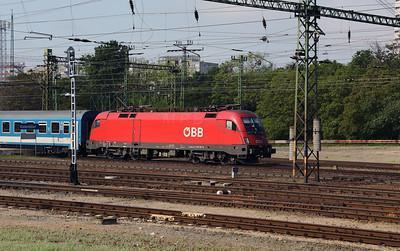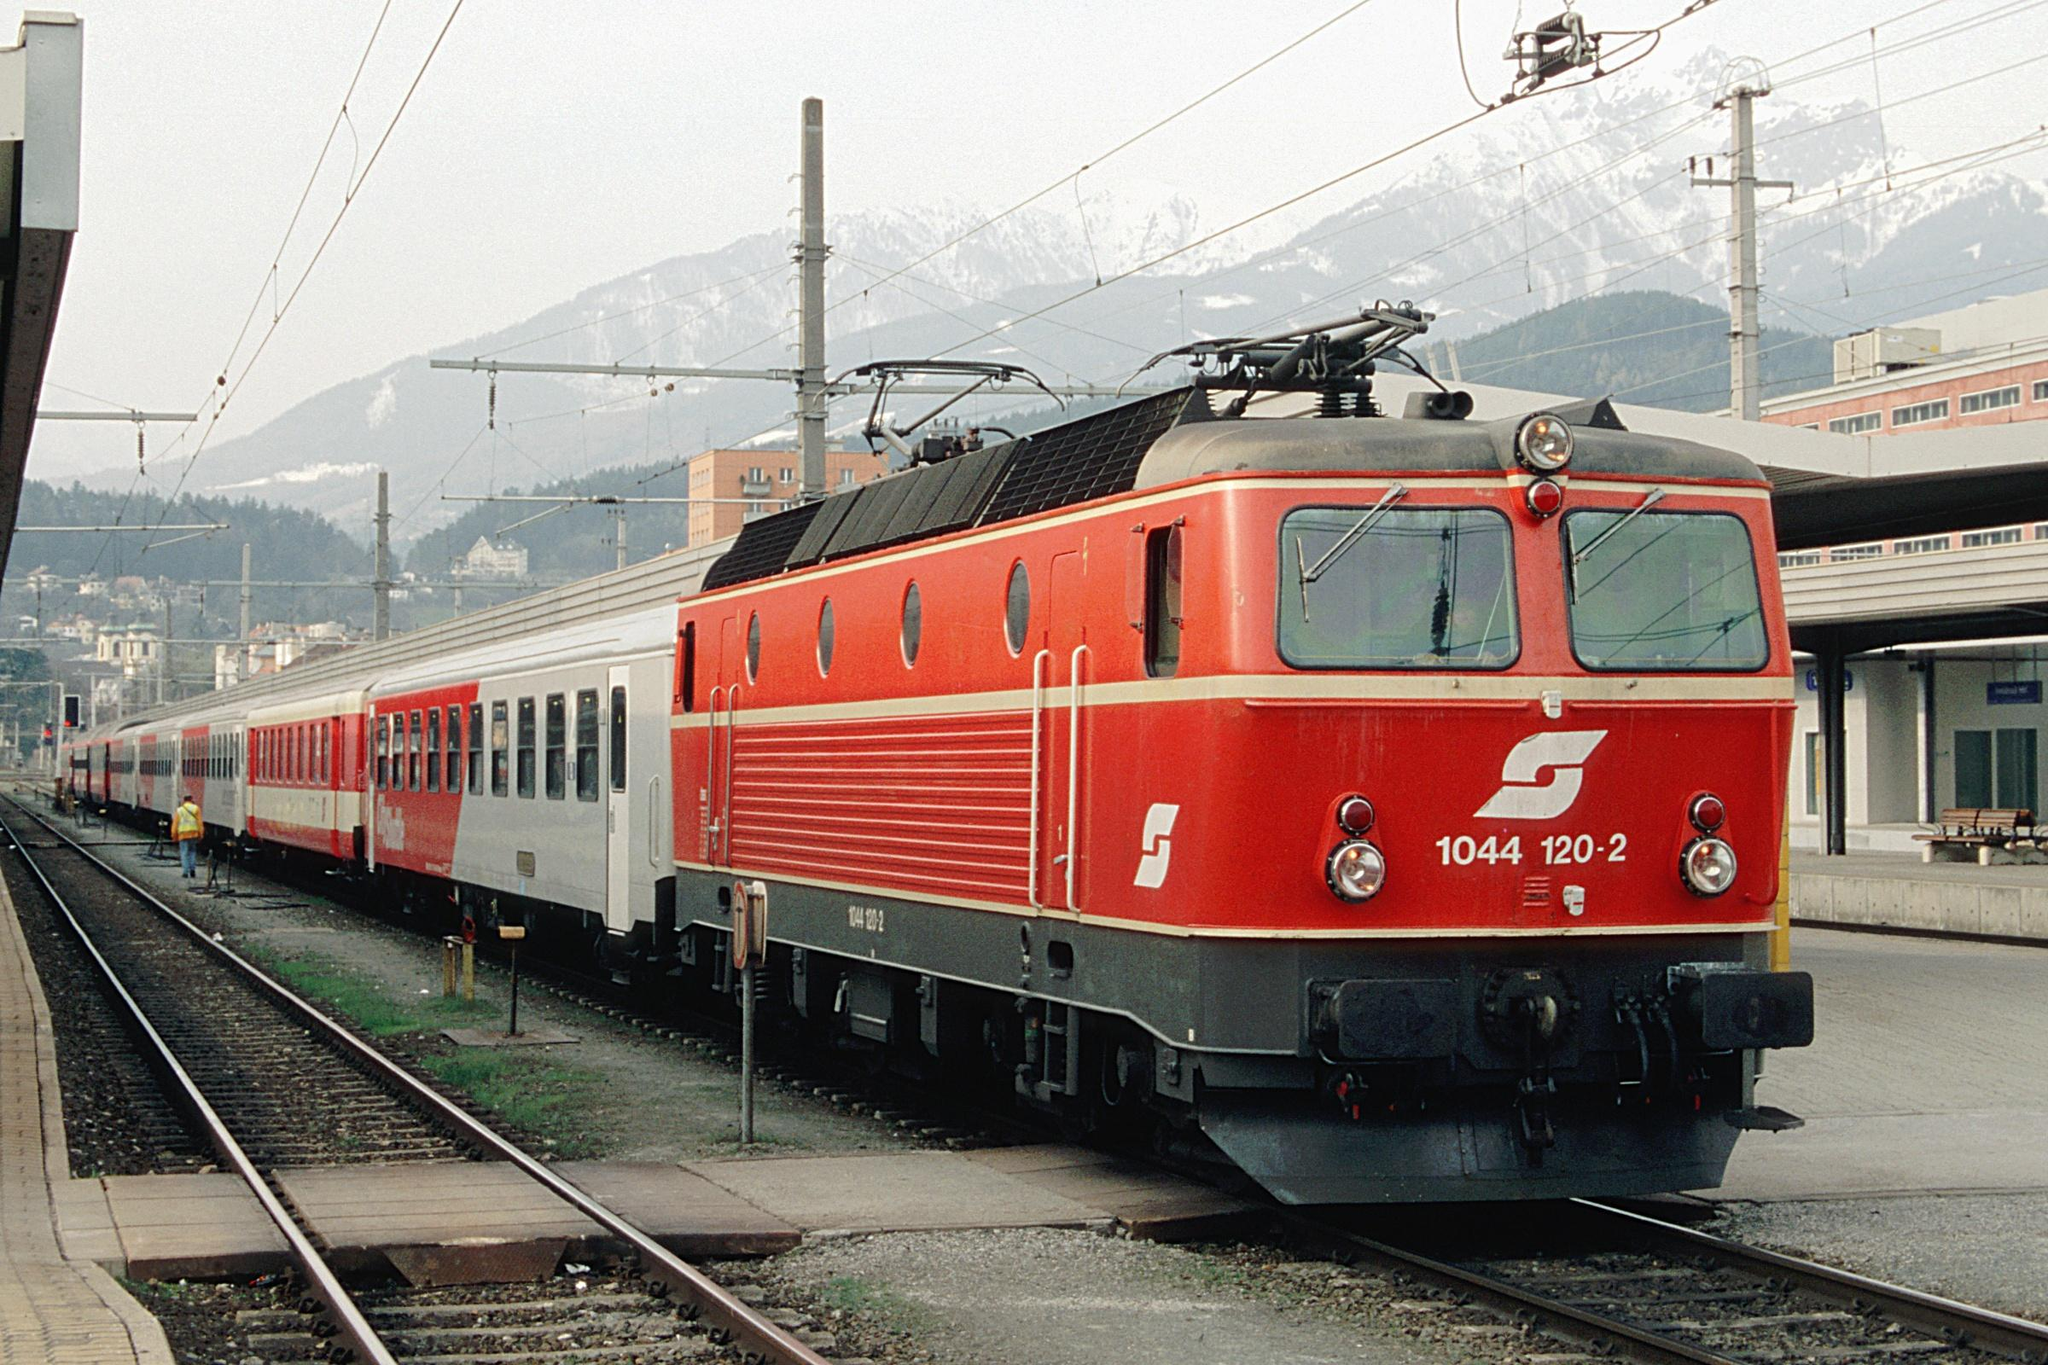The first image is the image on the left, the second image is the image on the right. Given the left and right images, does the statement "One image shows a leftward headed train, and the other shows a rightward angled train." hold true? Answer yes or no. No. 